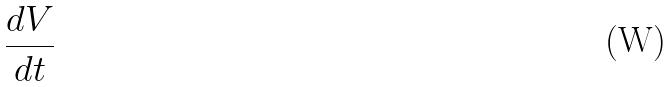Convert formula to latex. <formula><loc_0><loc_0><loc_500><loc_500>\frac { d V } { d t }</formula> 